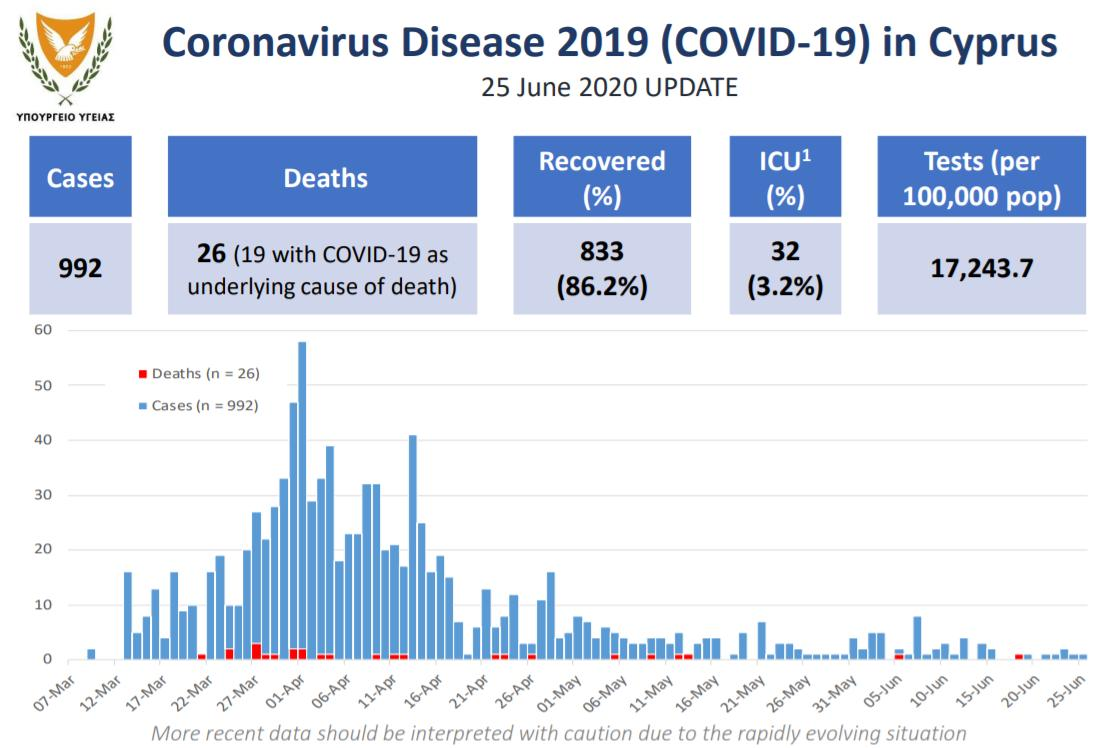Identify some key points in this picture. The average number of tests per 100,000 population in the United States has been approximately 17,243.7. Out of 26 deaths, 7 of them were due to causes other than COVID-19. Thirty-two hundredths of cases were in the ICU. On a particular day, the highest death count was reported in March. The recovery rate is 86.2%. 